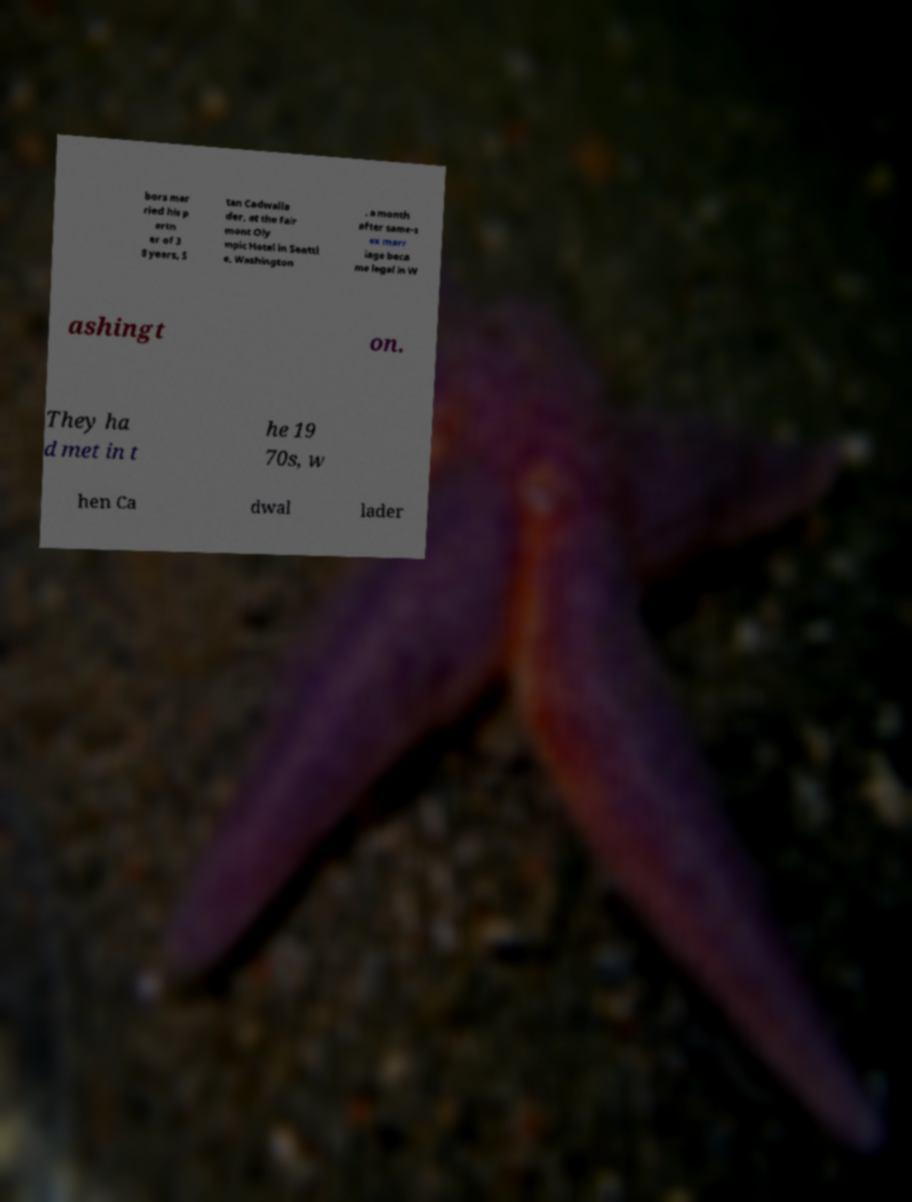There's text embedded in this image that I need extracted. Can you transcribe it verbatim? bors mar ried his p artn er of 3 8 years, S tan Cadwalla der, at the Fair mont Oly mpic Hotel in Seattl e, Washington , a month after same-s ex marr iage beca me legal in W ashingt on. They ha d met in t he 19 70s, w hen Ca dwal lader 